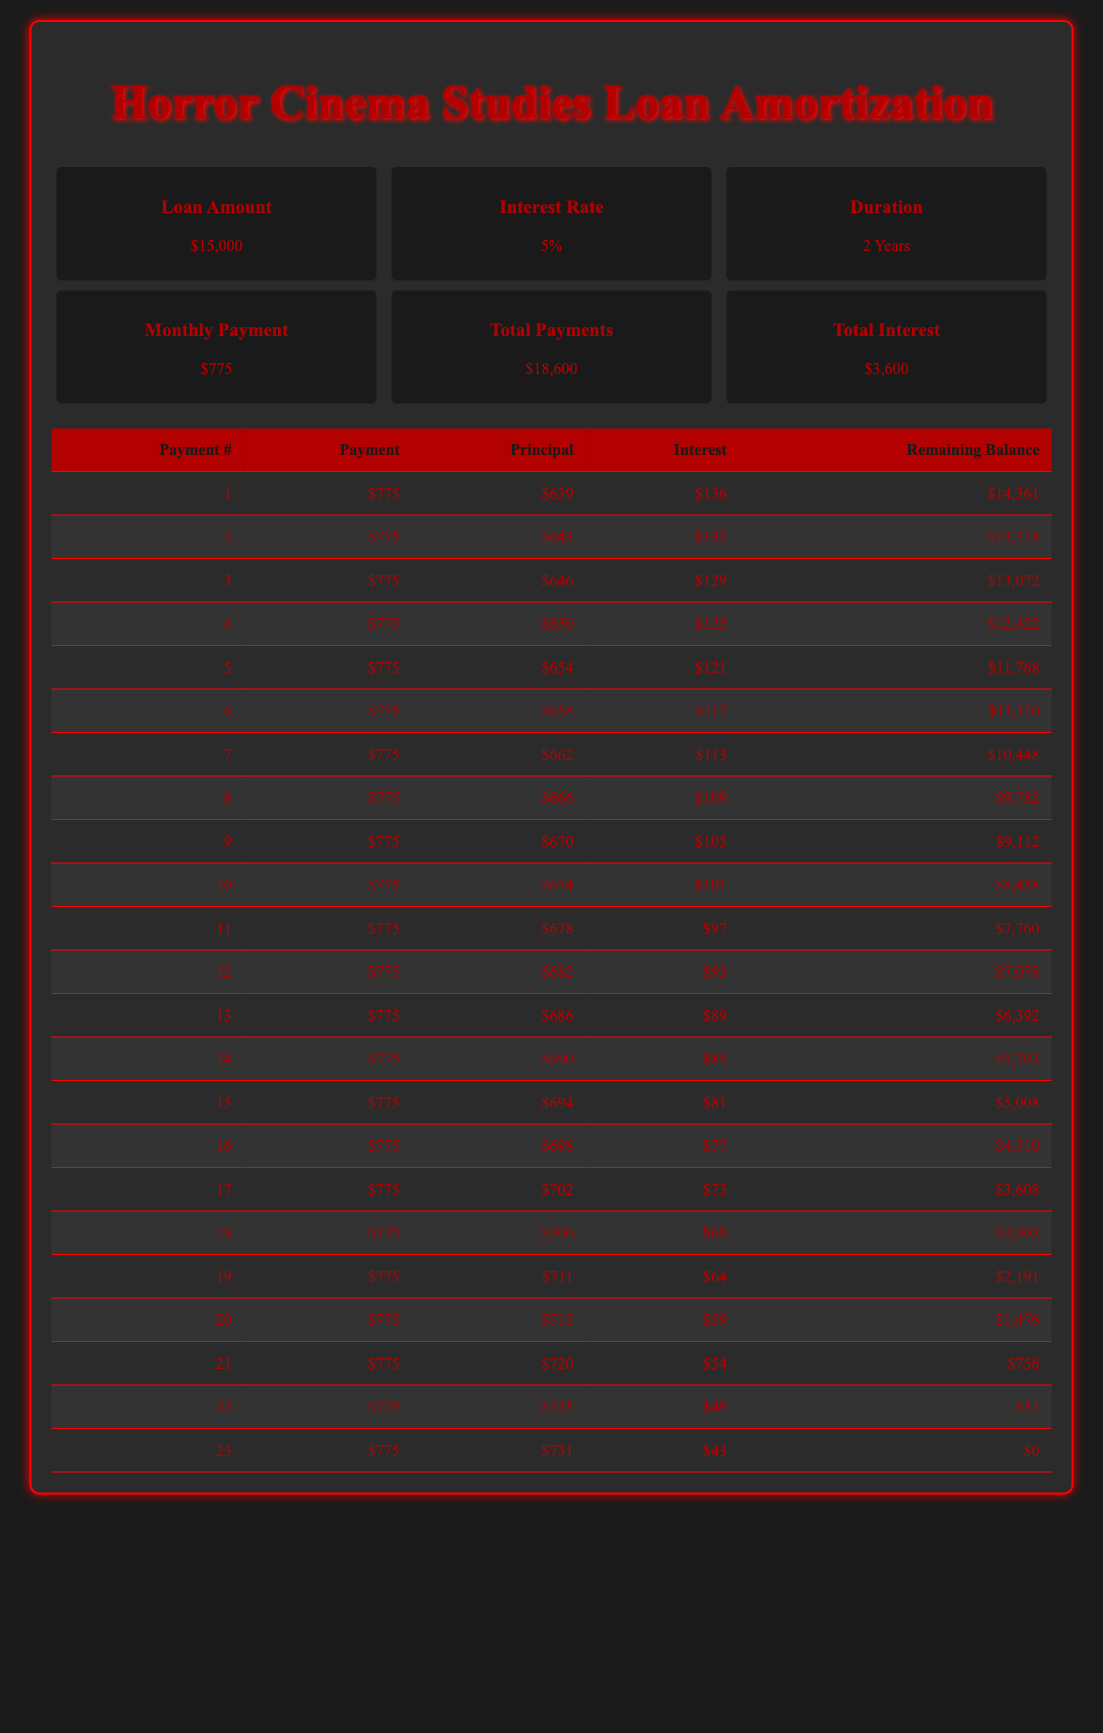What is the total amount paid by the end of the loan period? The total payments made over the loan period are listed in the summary section of the table, which indicates that the total payments amount to $18,600.
Answer: 18600 How much of the first month's payment goes towards principal? Referring to the first row of the amortization schedule, the principal amount for the first payment is $639.
Answer: 639 What is the remaining balance after the 10th payment? The remaining balance after the 10th payment can be found in the 10th row of the amortization schedule, which shows the remaining balance is $8,438.
Answer: 8438 What is the total interest paid over the loan duration? The summary section shows that the total interest paid over the course of the loan is $3,600.
Answer: 3600 How many payments have more principal repayment than interest repayment? By examining the table, we can see that from the 1st to the 23rd payment, all payments from the 14th to the 23rd payment have a greater principal repayment compared to interest. Hence, 10 payments have more towards the principal.
Answer: 10 Is the total interest paid more than the total principal paid by the end? The total principal paid can be calculated by taking the loan amount of $15,000 and subtracting the total interest of $3,600, resulting in $18,600 (total payments) - $3,600 (total interest) = $15,000. Thus, the statement is false.
Answer: No What is the average monthly principal payment over the entire loan duration? The total amount of principal paid at the end of the loan is $15,000. Since there were 23 payments made, the average monthly principal payment is calculated as $15,000 / 23 = approximately $652.17.
Answer: 652.17 How much was the principal payment in the last month compared to the first month? The principal payment in the last month (23rd payment) is $731, while in the first month (1st payment) it is $639. Therefore, the last month's principal payment is higher than the first month’s by $731 - $639 = $92.
Answer: $92 What is the remaining balance after the 15th payment? The remaining balance can be found in the amortization schedule and is shown to be $5,008 after the 15th payment.
Answer: 5008 